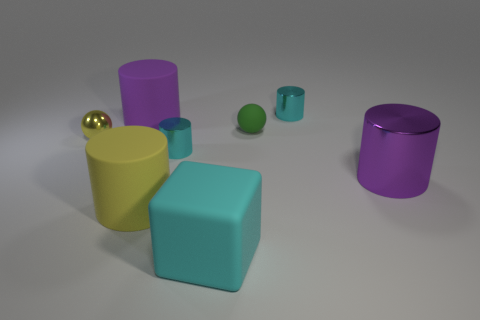Subtract all yellow cylinders. How many cylinders are left? 4 Subtract all large yellow rubber cylinders. How many cylinders are left? 4 Subtract all brown cylinders. Subtract all red balls. How many cylinders are left? 5 Add 2 big purple cylinders. How many objects exist? 10 Subtract all blocks. How many objects are left? 7 Add 7 small cyan things. How many small cyan things are left? 9 Add 2 tiny blue metal objects. How many tiny blue metal objects exist? 2 Subtract 0 green cubes. How many objects are left? 8 Subtract all purple matte cylinders. Subtract all large rubber cylinders. How many objects are left? 5 